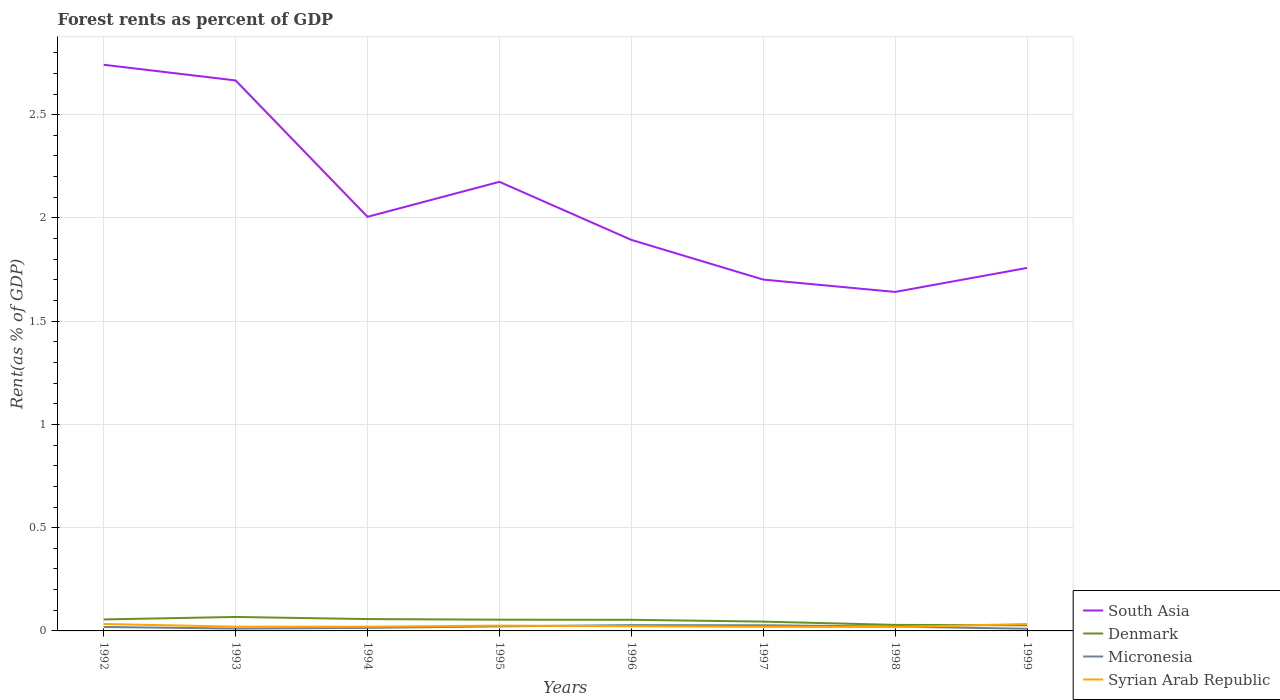How many different coloured lines are there?
Provide a short and direct response. 4. Does the line corresponding to Syrian Arab Republic intersect with the line corresponding to Micronesia?
Offer a very short reply. Yes. Across all years, what is the maximum forest rent in South Asia?
Your answer should be very brief. 1.64. What is the total forest rent in Syrian Arab Republic in the graph?
Your answer should be compact. -0.01. What is the difference between the highest and the second highest forest rent in Micronesia?
Offer a terse response. 0.02. Is the forest rent in South Asia strictly greater than the forest rent in Denmark over the years?
Make the answer very short. No. How many lines are there?
Make the answer very short. 4. How many years are there in the graph?
Provide a succinct answer. 8. Are the values on the major ticks of Y-axis written in scientific E-notation?
Your answer should be very brief. No. How many legend labels are there?
Provide a short and direct response. 4. How are the legend labels stacked?
Your answer should be compact. Vertical. What is the title of the graph?
Offer a terse response. Forest rents as percent of GDP. Does "Angola" appear as one of the legend labels in the graph?
Your answer should be very brief. No. What is the label or title of the X-axis?
Your answer should be very brief. Years. What is the label or title of the Y-axis?
Your answer should be compact. Rent(as % of GDP). What is the Rent(as % of GDP) of South Asia in 1992?
Provide a succinct answer. 2.74. What is the Rent(as % of GDP) of Denmark in 1992?
Your answer should be compact. 0.06. What is the Rent(as % of GDP) in Micronesia in 1992?
Ensure brevity in your answer.  0.02. What is the Rent(as % of GDP) in Syrian Arab Republic in 1992?
Provide a short and direct response. 0.03. What is the Rent(as % of GDP) in South Asia in 1993?
Make the answer very short. 2.67. What is the Rent(as % of GDP) in Denmark in 1993?
Your response must be concise. 0.07. What is the Rent(as % of GDP) in Micronesia in 1993?
Offer a terse response. 0.01. What is the Rent(as % of GDP) in Syrian Arab Republic in 1993?
Your answer should be very brief. 0.02. What is the Rent(as % of GDP) of South Asia in 1994?
Offer a very short reply. 2.01. What is the Rent(as % of GDP) of Denmark in 1994?
Your response must be concise. 0.06. What is the Rent(as % of GDP) in Micronesia in 1994?
Your response must be concise. 0.01. What is the Rent(as % of GDP) of Syrian Arab Republic in 1994?
Give a very brief answer. 0.02. What is the Rent(as % of GDP) in South Asia in 1995?
Your answer should be compact. 2.17. What is the Rent(as % of GDP) of Denmark in 1995?
Give a very brief answer. 0.05. What is the Rent(as % of GDP) of Micronesia in 1995?
Make the answer very short. 0.02. What is the Rent(as % of GDP) in Syrian Arab Republic in 1995?
Provide a short and direct response. 0.03. What is the Rent(as % of GDP) of South Asia in 1996?
Make the answer very short. 1.89. What is the Rent(as % of GDP) of Denmark in 1996?
Your response must be concise. 0.05. What is the Rent(as % of GDP) of Micronesia in 1996?
Offer a very short reply. 0.03. What is the Rent(as % of GDP) in Syrian Arab Republic in 1996?
Offer a very short reply. 0.02. What is the Rent(as % of GDP) of South Asia in 1997?
Keep it short and to the point. 1.7. What is the Rent(as % of GDP) in Denmark in 1997?
Your response must be concise. 0.05. What is the Rent(as % of GDP) of Micronesia in 1997?
Offer a very short reply. 0.03. What is the Rent(as % of GDP) of Syrian Arab Republic in 1997?
Give a very brief answer. 0.02. What is the Rent(as % of GDP) of South Asia in 1998?
Offer a terse response. 1.64. What is the Rent(as % of GDP) of Denmark in 1998?
Your answer should be compact. 0.03. What is the Rent(as % of GDP) of Micronesia in 1998?
Provide a short and direct response. 0.02. What is the Rent(as % of GDP) of Syrian Arab Republic in 1998?
Keep it short and to the point. 0.02. What is the Rent(as % of GDP) of South Asia in 1999?
Provide a short and direct response. 1.76. What is the Rent(as % of GDP) in Denmark in 1999?
Offer a very short reply. 0.03. What is the Rent(as % of GDP) in Micronesia in 1999?
Keep it short and to the point. 0.01. What is the Rent(as % of GDP) in Syrian Arab Republic in 1999?
Make the answer very short. 0.03. Across all years, what is the maximum Rent(as % of GDP) in South Asia?
Your answer should be compact. 2.74. Across all years, what is the maximum Rent(as % of GDP) in Denmark?
Ensure brevity in your answer.  0.07. Across all years, what is the maximum Rent(as % of GDP) of Micronesia?
Your response must be concise. 0.03. Across all years, what is the maximum Rent(as % of GDP) in Syrian Arab Republic?
Your answer should be compact. 0.03. Across all years, what is the minimum Rent(as % of GDP) in South Asia?
Offer a very short reply. 1.64. Across all years, what is the minimum Rent(as % of GDP) of Denmark?
Give a very brief answer. 0.03. Across all years, what is the minimum Rent(as % of GDP) of Micronesia?
Keep it short and to the point. 0.01. Across all years, what is the minimum Rent(as % of GDP) in Syrian Arab Republic?
Your answer should be compact. 0.02. What is the total Rent(as % of GDP) of South Asia in the graph?
Give a very brief answer. 16.58. What is the total Rent(as % of GDP) in Denmark in the graph?
Offer a very short reply. 0.39. What is the total Rent(as % of GDP) in Micronesia in the graph?
Ensure brevity in your answer.  0.15. What is the total Rent(as % of GDP) of Syrian Arab Republic in the graph?
Offer a very short reply. 0.2. What is the difference between the Rent(as % of GDP) of South Asia in 1992 and that in 1993?
Provide a short and direct response. 0.08. What is the difference between the Rent(as % of GDP) in Denmark in 1992 and that in 1993?
Make the answer very short. -0.01. What is the difference between the Rent(as % of GDP) in Micronesia in 1992 and that in 1993?
Your response must be concise. 0.01. What is the difference between the Rent(as % of GDP) in Syrian Arab Republic in 1992 and that in 1993?
Your response must be concise. 0.01. What is the difference between the Rent(as % of GDP) of South Asia in 1992 and that in 1994?
Ensure brevity in your answer.  0.74. What is the difference between the Rent(as % of GDP) of Denmark in 1992 and that in 1994?
Offer a terse response. -0. What is the difference between the Rent(as % of GDP) of Micronesia in 1992 and that in 1994?
Give a very brief answer. 0. What is the difference between the Rent(as % of GDP) in Syrian Arab Republic in 1992 and that in 1994?
Ensure brevity in your answer.  0.01. What is the difference between the Rent(as % of GDP) of South Asia in 1992 and that in 1995?
Offer a terse response. 0.57. What is the difference between the Rent(as % of GDP) in Denmark in 1992 and that in 1995?
Offer a terse response. 0. What is the difference between the Rent(as % of GDP) of Micronesia in 1992 and that in 1995?
Provide a succinct answer. -0. What is the difference between the Rent(as % of GDP) of Syrian Arab Republic in 1992 and that in 1995?
Ensure brevity in your answer.  0.01. What is the difference between the Rent(as % of GDP) in South Asia in 1992 and that in 1996?
Offer a terse response. 0.85. What is the difference between the Rent(as % of GDP) of Denmark in 1992 and that in 1996?
Your answer should be very brief. 0. What is the difference between the Rent(as % of GDP) of Micronesia in 1992 and that in 1996?
Ensure brevity in your answer.  -0.01. What is the difference between the Rent(as % of GDP) in Syrian Arab Republic in 1992 and that in 1996?
Provide a short and direct response. 0.01. What is the difference between the Rent(as % of GDP) in South Asia in 1992 and that in 1997?
Keep it short and to the point. 1.04. What is the difference between the Rent(as % of GDP) in Denmark in 1992 and that in 1997?
Your answer should be very brief. 0.01. What is the difference between the Rent(as % of GDP) in Micronesia in 1992 and that in 1997?
Provide a succinct answer. -0.01. What is the difference between the Rent(as % of GDP) in Syrian Arab Republic in 1992 and that in 1997?
Offer a very short reply. 0.01. What is the difference between the Rent(as % of GDP) of South Asia in 1992 and that in 1998?
Provide a succinct answer. 1.1. What is the difference between the Rent(as % of GDP) in Denmark in 1992 and that in 1998?
Your answer should be very brief. 0.03. What is the difference between the Rent(as % of GDP) of Micronesia in 1992 and that in 1998?
Offer a terse response. -0. What is the difference between the Rent(as % of GDP) in Syrian Arab Republic in 1992 and that in 1998?
Ensure brevity in your answer.  0.01. What is the difference between the Rent(as % of GDP) of South Asia in 1992 and that in 1999?
Offer a terse response. 0.98. What is the difference between the Rent(as % of GDP) in Denmark in 1992 and that in 1999?
Your response must be concise. 0.03. What is the difference between the Rent(as % of GDP) of Micronesia in 1992 and that in 1999?
Give a very brief answer. 0.01. What is the difference between the Rent(as % of GDP) of South Asia in 1993 and that in 1994?
Make the answer very short. 0.66. What is the difference between the Rent(as % of GDP) of Denmark in 1993 and that in 1994?
Keep it short and to the point. 0.01. What is the difference between the Rent(as % of GDP) in Micronesia in 1993 and that in 1994?
Give a very brief answer. -0. What is the difference between the Rent(as % of GDP) of South Asia in 1993 and that in 1995?
Your answer should be compact. 0.49. What is the difference between the Rent(as % of GDP) in Denmark in 1993 and that in 1995?
Keep it short and to the point. 0.01. What is the difference between the Rent(as % of GDP) in Micronesia in 1993 and that in 1995?
Your response must be concise. -0.01. What is the difference between the Rent(as % of GDP) of Syrian Arab Republic in 1993 and that in 1995?
Offer a terse response. -0.01. What is the difference between the Rent(as % of GDP) of South Asia in 1993 and that in 1996?
Your answer should be compact. 0.77. What is the difference between the Rent(as % of GDP) in Denmark in 1993 and that in 1996?
Provide a short and direct response. 0.01. What is the difference between the Rent(as % of GDP) of Micronesia in 1993 and that in 1996?
Offer a terse response. -0.02. What is the difference between the Rent(as % of GDP) in Syrian Arab Republic in 1993 and that in 1996?
Offer a terse response. -0. What is the difference between the Rent(as % of GDP) of South Asia in 1993 and that in 1997?
Your answer should be compact. 0.96. What is the difference between the Rent(as % of GDP) of Denmark in 1993 and that in 1997?
Ensure brevity in your answer.  0.02. What is the difference between the Rent(as % of GDP) of Micronesia in 1993 and that in 1997?
Your answer should be very brief. -0.02. What is the difference between the Rent(as % of GDP) in Syrian Arab Republic in 1993 and that in 1997?
Provide a succinct answer. 0. What is the difference between the Rent(as % of GDP) of South Asia in 1993 and that in 1998?
Ensure brevity in your answer.  1.02. What is the difference between the Rent(as % of GDP) in Denmark in 1993 and that in 1998?
Keep it short and to the point. 0.04. What is the difference between the Rent(as % of GDP) of Micronesia in 1993 and that in 1998?
Keep it short and to the point. -0.01. What is the difference between the Rent(as % of GDP) in Syrian Arab Republic in 1993 and that in 1998?
Make the answer very short. 0. What is the difference between the Rent(as % of GDP) in South Asia in 1993 and that in 1999?
Offer a very short reply. 0.91. What is the difference between the Rent(as % of GDP) of Denmark in 1993 and that in 1999?
Your response must be concise. 0.04. What is the difference between the Rent(as % of GDP) in Micronesia in 1993 and that in 1999?
Your answer should be compact. 0. What is the difference between the Rent(as % of GDP) of Syrian Arab Republic in 1993 and that in 1999?
Make the answer very short. -0.01. What is the difference between the Rent(as % of GDP) of South Asia in 1994 and that in 1995?
Your answer should be very brief. -0.17. What is the difference between the Rent(as % of GDP) of Denmark in 1994 and that in 1995?
Offer a terse response. 0. What is the difference between the Rent(as % of GDP) of Micronesia in 1994 and that in 1995?
Your answer should be compact. -0.01. What is the difference between the Rent(as % of GDP) of Syrian Arab Republic in 1994 and that in 1995?
Offer a very short reply. -0.01. What is the difference between the Rent(as % of GDP) in South Asia in 1994 and that in 1996?
Provide a short and direct response. 0.11. What is the difference between the Rent(as % of GDP) in Denmark in 1994 and that in 1996?
Your response must be concise. 0. What is the difference between the Rent(as % of GDP) of Micronesia in 1994 and that in 1996?
Your response must be concise. -0.01. What is the difference between the Rent(as % of GDP) of Syrian Arab Republic in 1994 and that in 1996?
Ensure brevity in your answer.  -0. What is the difference between the Rent(as % of GDP) of South Asia in 1994 and that in 1997?
Offer a terse response. 0.3. What is the difference between the Rent(as % of GDP) in Denmark in 1994 and that in 1997?
Offer a terse response. 0.01. What is the difference between the Rent(as % of GDP) in Micronesia in 1994 and that in 1997?
Offer a very short reply. -0.01. What is the difference between the Rent(as % of GDP) of Syrian Arab Republic in 1994 and that in 1997?
Ensure brevity in your answer.  0. What is the difference between the Rent(as % of GDP) in South Asia in 1994 and that in 1998?
Provide a succinct answer. 0.36. What is the difference between the Rent(as % of GDP) in Denmark in 1994 and that in 1998?
Ensure brevity in your answer.  0.03. What is the difference between the Rent(as % of GDP) of Micronesia in 1994 and that in 1998?
Give a very brief answer. -0.01. What is the difference between the Rent(as % of GDP) of Syrian Arab Republic in 1994 and that in 1998?
Provide a succinct answer. 0. What is the difference between the Rent(as % of GDP) of South Asia in 1994 and that in 1999?
Make the answer very short. 0.25. What is the difference between the Rent(as % of GDP) in Micronesia in 1994 and that in 1999?
Make the answer very short. 0. What is the difference between the Rent(as % of GDP) in Syrian Arab Republic in 1994 and that in 1999?
Offer a very short reply. -0.01. What is the difference between the Rent(as % of GDP) of South Asia in 1995 and that in 1996?
Provide a short and direct response. 0.28. What is the difference between the Rent(as % of GDP) of Denmark in 1995 and that in 1996?
Provide a succinct answer. 0. What is the difference between the Rent(as % of GDP) in Micronesia in 1995 and that in 1996?
Your answer should be very brief. -0.01. What is the difference between the Rent(as % of GDP) in Syrian Arab Republic in 1995 and that in 1996?
Give a very brief answer. 0. What is the difference between the Rent(as % of GDP) in South Asia in 1995 and that in 1997?
Your answer should be very brief. 0.47. What is the difference between the Rent(as % of GDP) in Denmark in 1995 and that in 1997?
Offer a terse response. 0.01. What is the difference between the Rent(as % of GDP) in Micronesia in 1995 and that in 1997?
Offer a terse response. -0.01. What is the difference between the Rent(as % of GDP) of Syrian Arab Republic in 1995 and that in 1997?
Your response must be concise. 0.01. What is the difference between the Rent(as % of GDP) in South Asia in 1995 and that in 1998?
Offer a terse response. 0.53. What is the difference between the Rent(as % of GDP) in Denmark in 1995 and that in 1998?
Your response must be concise. 0.03. What is the difference between the Rent(as % of GDP) of Syrian Arab Republic in 1995 and that in 1998?
Your answer should be very brief. 0.01. What is the difference between the Rent(as % of GDP) in South Asia in 1995 and that in 1999?
Give a very brief answer. 0.42. What is the difference between the Rent(as % of GDP) in Denmark in 1995 and that in 1999?
Keep it short and to the point. 0.03. What is the difference between the Rent(as % of GDP) of Micronesia in 1995 and that in 1999?
Your answer should be very brief. 0.01. What is the difference between the Rent(as % of GDP) in Syrian Arab Republic in 1995 and that in 1999?
Keep it short and to the point. -0.01. What is the difference between the Rent(as % of GDP) in South Asia in 1996 and that in 1997?
Provide a succinct answer. 0.19. What is the difference between the Rent(as % of GDP) of Denmark in 1996 and that in 1997?
Offer a terse response. 0.01. What is the difference between the Rent(as % of GDP) of Micronesia in 1996 and that in 1997?
Make the answer very short. 0. What is the difference between the Rent(as % of GDP) in Syrian Arab Republic in 1996 and that in 1997?
Keep it short and to the point. 0. What is the difference between the Rent(as % of GDP) of South Asia in 1996 and that in 1998?
Your response must be concise. 0.25. What is the difference between the Rent(as % of GDP) of Denmark in 1996 and that in 1998?
Offer a very short reply. 0.02. What is the difference between the Rent(as % of GDP) in Micronesia in 1996 and that in 1998?
Keep it short and to the point. 0.01. What is the difference between the Rent(as % of GDP) in Syrian Arab Republic in 1996 and that in 1998?
Your response must be concise. 0. What is the difference between the Rent(as % of GDP) of South Asia in 1996 and that in 1999?
Give a very brief answer. 0.14. What is the difference between the Rent(as % of GDP) in Denmark in 1996 and that in 1999?
Offer a very short reply. 0.03. What is the difference between the Rent(as % of GDP) of Micronesia in 1996 and that in 1999?
Keep it short and to the point. 0.02. What is the difference between the Rent(as % of GDP) of Syrian Arab Republic in 1996 and that in 1999?
Make the answer very short. -0.01. What is the difference between the Rent(as % of GDP) in South Asia in 1997 and that in 1998?
Offer a very short reply. 0.06. What is the difference between the Rent(as % of GDP) in Denmark in 1997 and that in 1998?
Give a very brief answer. 0.02. What is the difference between the Rent(as % of GDP) of Micronesia in 1997 and that in 1998?
Your answer should be compact. 0.01. What is the difference between the Rent(as % of GDP) in Syrian Arab Republic in 1997 and that in 1998?
Offer a terse response. 0. What is the difference between the Rent(as % of GDP) of South Asia in 1997 and that in 1999?
Ensure brevity in your answer.  -0.06. What is the difference between the Rent(as % of GDP) in Denmark in 1997 and that in 1999?
Provide a succinct answer. 0.02. What is the difference between the Rent(as % of GDP) in Micronesia in 1997 and that in 1999?
Offer a terse response. 0.02. What is the difference between the Rent(as % of GDP) in Syrian Arab Republic in 1997 and that in 1999?
Keep it short and to the point. -0.01. What is the difference between the Rent(as % of GDP) of South Asia in 1998 and that in 1999?
Provide a short and direct response. -0.12. What is the difference between the Rent(as % of GDP) of Denmark in 1998 and that in 1999?
Give a very brief answer. 0. What is the difference between the Rent(as % of GDP) of Micronesia in 1998 and that in 1999?
Offer a terse response. 0.01. What is the difference between the Rent(as % of GDP) of Syrian Arab Republic in 1998 and that in 1999?
Provide a short and direct response. -0.01. What is the difference between the Rent(as % of GDP) in South Asia in 1992 and the Rent(as % of GDP) in Denmark in 1993?
Keep it short and to the point. 2.67. What is the difference between the Rent(as % of GDP) of South Asia in 1992 and the Rent(as % of GDP) of Micronesia in 1993?
Your response must be concise. 2.73. What is the difference between the Rent(as % of GDP) of South Asia in 1992 and the Rent(as % of GDP) of Syrian Arab Republic in 1993?
Ensure brevity in your answer.  2.72. What is the difference between the Rent(as % of GDP) of Denmark in 1992 and the Rent(as % of GDP) of Micronesia in 1993?
Your answer should be very brief. 0.04. What is the difference between the Rent(as % of GDP) of Denmark in 1992 and the Rent(as % of GDP) of Syrian Arab Republic in 1993?
Keep it short and to the point. 0.04. What is the difference between the Rent(as % of GDP) in Micronesia in 1992 and the Rent(as % of GDP) in Syrian Arab Republic in 1993?
Offer a very short reply. -0. What is the difference between the Rent(as % of GDP) of South Asia in 1992 and the Rent(as % of GDP) of Denmark in 1994?
Your answer should be compact. 2.68. What is the difference between the Rent(as % of GDP) of South Asia in 1992 and the Rent(as % of GDP) of Micronesia in 1994?
Your answer should be very brief. 2.73. What is the difference between the Rent(as % of GDP) in South Asia in 1992 and the Rent(as % of GDP) in Syrian Arab Republic in 1994?
Your response must be concise. 2.72. What is the difference between the Rent(as % of GDP) in Denmark in 1992 and the Rent(as % of GDP) in Micronesia in 1994?
Ensure brevity in your answer.  0.04. What is the difference between the Rent(as % of GDP) in Denmark in 1992 and the Rent(as % of GDP) in Syrian Arab Republic in 1994?
Your answer should be very brief. 0.04. What is the difference between the Rent(as % of GDP) in Micronesia in 1992 and the Rent(as % of GDP) in Syrian Arab Republic in 1994?
Make the answer very short. -0. What is the difference between the Rent(as % of GDP) in South Asia in 1992 and the Rent(as % of GDP) in Denmark in 1995?
Offer a very short reply. 2.69. What is the difference between the Rent(as % of GDP) in South Asia in 1992 and the Rent(as % of GDP) in Micronesia in 1995?
Ensure brevity in your answer.  2.72. What is the difference between the Rent(as % of GDP) of South Asia in 1992 and the Rent(as % of GDP) of Syrian Arab Republic in 1995?
Provide a short and direct response. 2.72. What is the difference between the Rent(as % of GDP) of Denmark in 1992 and the Rent(as % of GDP) of Micronesia in 1995?
Provide a short and direct response. 0.03. What is the difference between the Rent(as % of GDP) of Denmark in 1992 and the Rent(as % of GDP) of Syrian Arab Republic in 1995?
Provide a succinct answer. 0.03. What is the difference between the Rent(as % of GDP) of Micronesia in 1992 and the Rent(as % of GDP) of Syrian Arab Republic in 1995?
Ensure brevity in your answer.  -0.01. What is the difference between the Rent(as % of GDP) in South Asia in 1992 and the Rent(as % of GDP) in Denmark in 1996?
Your answer should be very brief. 2.69. What is the difference between the Rent(as % of GDP) in South Asia in 1992 and the Rent(as % of GDP) in Micronesia in 1996?
Make the answer very short. 2.71. What is the difference between the Rent(as % of GDP) in South Asia in 1992 and the Rent(as % of GDP) in Syrian Arab Republic in 1996?
Give a very brief answer. 2.72. What is the difference between the Rent(as % of GDP) of Denmark in 1992 and the Rent(as % of GDP) of Micronesia in 1996?
Ensure brevity in your answer.  0.03. What is the difference between the Rent(as % of GDP) in Denmark in 1992 and the Rent(as % of GDP) in Syrian Arab Republic in 1996?
Offer a very short reply. 0.03. What is the difference between the Rent(as % of GDP) in Micronesia in 1992 and the Rent(as % of GDP) in Syrian Arab Republic in 1996?
Ensure brevity in your answer.  -0. What is the difference between the Rent(as % of GDP) in South Asia in 1992 and the Rent(as % of GDP) in Denmark in 1997?
Keep it short and to the point. 2.7. What is the difference between the Rent(as % of GDP) of South Asia in 1992 and the Rent(as % of GDP) of Micronesia in 1997?
Your answer should be compact. 2.71. What is the difference between the Rent(as % of GDP) in South Asia in 1992 and the Rent(as % of GDP) in Syrian Arab Republic in 1997?
Your answer should be very brief. 2.72. What is the difference between the Rent(as % of GDP) of Denmark in 1992 and the Rent(as % of GDP) of Micronesia in 1997?
Ensure brevity in your answer.  0.03. What is the difference between the Rent(as % of GDP) in Denmark in 1992 and the Rent(as % of GDP) in Syrian Arab Republic in 1997?
Make the answer very short. 0.04. What is the difference between the Rent(as % of GDP) of Micronesia in 1992 and the Rent(as % of GDP) of Syrian Arab Republic in 1997?
Ensure brevity in your answer.  -0. What is the difference between the Rent(as % of GDP) of South Asia in 1992 and the Rent(as % of GDP) of Denmark in 1998?
Provide a short and direct response. 2.71. What is the difference between the Rent(as % of GDP) in South Asia in 1992 and the Rent(as % of GDP) in Micronesia in 1998?
Offer a terse response. 2.72. What is the difference between the Rent(as % of GDP) of South Asia in 1992 and the Rent(as % of GDP) of Syrian Arab Republic in 1998?
Ensure brevity in your answer.  2.72. What is the difference between the Rent(as % of GDP) of Denmark in 1992 and the Rent(as % of GDP) of Micronesia in 1998?
Offer a terse response. 0.03. What is the difference between the Rent(as % of GDP) of Denmark in 1992 and the Rent(as % of GDP) of Syrian Arab Republic in 1998?
Provide a succinct answer. 0.04. What is the difference between the Rent(as % of GDP) of South Asia in 1992 and the Rent(as % of GDP) of Denmark in 1999?
Your answer should be compact. 2.71. What is the difference between the Rent(as % of GDP) in South Asia in 1992 and the Rent(as % of GDP) in Micronesia in 1999?
Make the answer very short. 2.73. What is the difference between the Rent(as % of GDP) in South Asia in 1992 and the Rent(as % of GDP) in Syrian Arab Republic in 1999?
Keep it short and to the point. 2.71. What is the difference between the Rent(as % of GDP) of Denmark in 1992 and the Rent(as % of GDP) of Micronesia in 1999?
Your response must be concise. 0.05. What is the difference between the Rent(as % of GDP) in Denmark in 1992 and the Rent(as % of GDP) in Syrian Arab Republic in 1999?
Keep it short and to the point. 0.02. What is the difference between the Rent(as % of GDP) in Micronesia in 1992 and the Rent(as % of GDP) in Syrian Arab Republic in 1999?
Your answer should be compact. -0.01. What is the difference between the Rent(as % of GDP) in South Asia in 1993 and the Rent(as % of GDP) in Denmark in 1994?
Offer a very short reply. 2.61. What is the difference between the Rent(as % of GDP) of South Asia in 1993 and the Rent(as % of GDP) of Micronesia in 1994?
Ensure brevity in your answer.  2.65. What is the difference between the Rent(as % of GDP) in South Asia in 1993 and the Rent(as % of GDP) in Syrian Arab Republic in 1994?
Your response must be concise. 2.65. What is the difference between the Rent(as % of GDP) in Denmark in 1993 and the Rent(as % of GDP) in Micronesia in 1994?
Provide a short and direct response. 0.05. What is the difference between the Rent(as % of GDP) of Denmark in 1993 and the Rent(as % of GDP) of Syrian Arab Republic in 1994?
Provide a succinct answer. 0.05. What is the difference between the Rent(as % of GDP) in Micronesia in 1993 and the Rent(as % of GDP) in Syrian Arab Republic in 1994?
Your answer should be very brief. -0.01. What is the difference between the Rent(as % of GDP) of South Asia in 1993 and the Rent(as % of GDP) of Denmark in 1995?
Your answer should be compact. 2.61. What is the difference between the Rent(as % of GDP) in South Asia in 1993 and the Rent(as % of GDP) in Micronesia in 1995?
Offer a terse response. 2.64. What is the difference between the Rent(as % of GDP) of South Asia in 1993 and the Rent(as % of GDP) of Syrian Arab Republic in 1995?
Make the answer very short. 2.64. What is the difference between the Rent(as % of GDP) of Denmark in 1993 and the Rent(as % of GDP) of Micronesia in 1995?
Your response must be concise. 0.05. What is the difference between the Rent(as % of GDP) of Denmark in 1993 and the Rent(as % of GDP) of Syrian Arab Republic in 1995?
Provide a short and direct response. 0.04. What is the difference between the Rent(as % of GDP) of Micronesia in 1993 and the Rent(as % of GDP) of Syrian Arab Republic in 1995?
Make the answer very short. -0.01. What is the difference between the Rent(as % of GDP) in South Asia in 1993 and the Rent(as % of GDP) in Denmark in 1996?
Provide a short and direct response. 2.61. What is the difference between the Rent(as % of GDP) in South Asia in 1993 and the Rent(as % of GDP) in Micronesia in 1996?
Offer a very short reply. 2.64. What is the difference between the Rent(as % of GDP) of South Asia in 1993 and the Rent(as % of GDP) of Syrian Arab Republic in 1996?
Make the answer very short. 2.64. What is the difference between the Rent(as % of GDP) of Denmark in 1993 and the Rent(as % of GDP) of Micronesia in 1996?
Provide a short and direct response. 0.04. What is the difference between the Rent(as % of GDP) of Denmark in 1993 and the Rent(as % of GDP) of Syrian Arab Republic in 1996?
Provide a succinct answer. 0.04. What is the difference between the Rent(as % of GDP) of Micronesia in 1993 and the Rent(as % of GDP) of Syrian Arab Republic in 1996?
Offer a very short reply. -0.01. What is the difference between the Rent(as % of GDP) in South Asia in 1993 and the Rent(as % of GDP) in Denmark in 1997?
Provide a succinct answer. 2.62. What is the difference between the Rent(as % of GDP) in South Asia in 1993 and the Rent(as % of GDP) in Micronesia in 1997?
Your answer should be compact. 2.64. What is the difference between the Rent(as % of GDP) of South Asia in 1993 and the Rent(as % of GDP) of Syrian Arab Republic in 1997?
Keep it short and to the point. 2.65. What is the difference between the Rent(as % of GDP) in Denmark in 1993 and the Rent(as % of GDP) in Micronesia in 1997?
Your response must be concise. 0.04. What is the difference between the Rent(as % of GDP) in Denmark in 1993 and the Rent(as % of GDP) in Syrian Arab Republic in 1997?
Your answer should be very brief. 0.05. What is the difference between the Rent(as % of GDP) in Micronesia in 1993 and the Rent(as % of GDP) in Syrian Arab Republic in 1997?
Make the answer very short. -0.01. What is the difference between the Rent(as % of GDP) in South Asia in 1993 and the Rent(as % of GDP) in Denmark in 1998?
Provide a succinct answer. 2.64. What is the difference between the Rent(as % of GDP) of South Asia in 1993 and the Rent(as % of GDP) of Micronesia in 1998?
Your answer should be very brief. 2.64. What is the difference between the Rent(as % of GDP) of South Asia in 1993 and the Rent(as % of GDP) of Syrian Arab Republic in 1998?
Provide a succinct answer. 2.65. What is the difference between the Rent(as % of GDP) of Denmark in 1993 and the Rent(as % of GDP) of Micronesia in 1998?
Give a very brief answer. 0.05. What is the difference between the Rent(as % of GDP) of Denmark in 1993 and the Rent(as % of GDP) of Syrian Arab Republic in 1998?
Your answer should be compact. 0.05. What is the difference between the Rent(as % of GDP) of Micronesia in 1993 and the Rent(as % of GDP) of Syrian Arab Republic in 1998?
Ensure brevity in your answer.  -0.01. What is the difference between the Rent(as % of GDP) of South Asia in 1993 and the Rent(as % of GDP) of Denmark in 1999?
Ensure brevity in your answer.  2.64. What is the difference between the Rent(as % of GDP) in South Asia in 1993 and the Rent(as % of GDP) in Micronesia in 1999?
Offer a very short reply. 2.66. What is the difference between the Rent(as % of GDP) in South Asia in 1993 and the Rent(as % of GDP) in Syrian Arab Republic in 1999?
Make the answer very short. 2.63. What is the difference between the Rent(as % of GDP) in Denmark in 1993 and the Rent(as % of GDP) in Micronesia in 1999?
Your answer should be compact. 0.06. What is the difference between the Rent(as % of GDP) of Denmark in 1993 and the Rent(as % of GDP) of Syrian Arab Republic in 1999?
Ensure brevity in your answer.  0.03. What is the difference between the Rent(as % of GDP) of Micronesia in 1993 and the Rent(as % of GDP) of Syrian Arab Republic in 1999?
Keep it short and to the point. -0.02. What is the difference between the Rent(as % of GDP) of South Asia in 1994 and the Rent(as % of GDP) of Denmark in 1995?
Provide a short and direct response. 1.95. What is the difference between the Rent(as % of GDP) of South Asia in 1994 and the Rent(as % of GDP) of Micronesia in 1995?
Your answer should be compact. 1.98. What is the difference between the Rent(as % of GDP) in South Asia in 1994 and the Rent(as % of GDP) in Syrian Arab Republic in 1995?
Provide a short and direct response. 1.98. What is the difference between the Rent(as % of GDP) of Denmark in 1994 and the Rent(as % of GDP) of Micronesia in 1995?
Ensure brevity in your answer.  0.04. What is the difference between the Rent(as % of GDP) of Denmark in 1994 and the Rent(as % of GDP) of Syrian Arab Republic in 1995?
Provide a short and direct response. 0.03. What is the difference between the Rent(as % of GDP) in Micronesia in 1994 and the Rent(as % of GDP) in Syrian Arab Republic in 1995?
Provide a succinct answer. -0.01. What is the difference between the Rent(as % of GDP) in South Asia in 1994 and the Rent(as % of GDP) in Denmark in 1996?
Your response must be concise. 1.95. What is the difference between the Rent(as % of GDP) in South Asia in 1994 and the Rent(as % of GDP) in Micronesia in 1996?
Your response must be concise. 1.98. What is the difference between the Rent(as % of GDP) in South Asia in 1994 and the Rent(as % of GDP) in Syrian Arab Republic in 1996?
Make the answer very short. 1.98. What is the difference between the Rent(as % of GDP) of Denmark in 1994 and the Rent(as % of GDP) of Micronesia in 1996?
Offer a very short reply. 0.03. What is the difference between the Rent(as % of GDP) of Denmark in 1994 and the Rent(as % of GDP) of Syrian Arab Republic in 1996?
Keep it short and to the point. 0.03. What is the difference between the Rent(as % of GDP) in Micronesia in 1994 and the Rent(as % of GDP) in Syrian Arab Republic in 1996?
Keep it short and to the point. -0.01. What is the difference between the Rent(as % of GDP) in South Asia in 1994 and the Rent(as % of GDP) in Denmark in 1997?
Keep it short and to the point. 1.96. What is the difference between the Rent(as % of GDP) of South Asia in 1994 and the Rent(as % of GDP) of Micronesia in 1997?
Give a very brief answer. 1.98. What is the difference between the Rent(as % of GDP) of South Asia in 1994 and the Rent(as % of GDP) of Syrian Arab Republic in 1997?
Your answer should be very brief. 1.99. What is the difference between the Rent(as % of GDP) of Denmark in 1994 and the Rent(as % of GDP) of Syrian Arab Republic in 1997?
Make the answer very short. 0.04. What is the difference between the Rent(as % of GDP) of Micronesia in 1994 and the Rent(as % of GDP) of Syrian Arab Republic in 1997?
Keep it short and to the point. -0.01. What is the difference between the Rent(as % of GDP) in South Asia in 1994 and the Rent(as % of GDP) in Denmark in 1998?
Your answer should be compact. 1.98. What is the difference between the Rent(as % of GDP) in South Asia in 1994 and the Rent(as % of GDP) in Micronesia in 1998?
Make the answer very short. 1.98. What is the difference between the Rent(as % of GDP) of South Asia in 1994 and the Rent(as % of GDP) of Syrian Arab Republic in 1998?
Your answer should be compact. 1.99. What is the difference between the Rent(as % of GDP) of Denmark in 1994 and the Rent(as % of GDP) of Micronesia in 1998?
Offer a very short reply. 0.04. What is the difference between the Rent(as % of GDP) of Denmark in 1994 and the Rent(as % of GDP) of Syrian Arab Republic in 1998?
Offer a terse response. 0.04. What is the difference between the Rent(as % of GDP) in Micronesia in 1994 and the Rent(as % of GDP) in Syrian Arab Republic in 1998?
Make the answer very short. -0. What is the difference between the Rent(as % of GDP) of South Asia in 1994 and the Rent(as % of GDP) of Denmark in 1999?
Offer a terse response. 1.98. What is the difference between the Rent(as % of GDP) in South Asia in 1994 and the Rent(as % of GDP) in Micronesia in 1999?
Provide a short and direct response. 1.99. What is the difference between the Rent(as % of GDP) of South Asia in 1994 and the Rent(as % of GDP) of Syrian Arab Republic in 1999?
Make the answer very short. 1.97. What is the difference between the Rent(as % of GDP) in Denmark in 1994 and the Rent(as % of GDP) in Micronesia in 1999?
Make the answer very short. 0.05. What is the difference between the Rent(as % of GDP) of Denmark in 1994 and the Rent(as % of GDP) of Syrian Arab Republic in 1999?
Give a very brief answer. 0.02. What is the difference between the Rent(as % of GDP) in Micronesia in 1994 and the Rent(as % of GDP) in Syrian Arab Republic in 1999?
Offer a very short reply. -0.02. What is the difference between the Rent(as % of GDP) in South Asia in 1995 and the Rent(as % of GDP) in Denmark in 1996?
Make the answer very short. 2.12. What is the difference between the Rent(as % of GDP) of South Asia in 1995 and the Rent(as % of GDP) of Micronesia in 1996?
Your answer should be compact. 2.15. What is the difference between the Rent(as % of GDP) in South Asia in 1995 and the Rent(as % of GDP) in Syrian Arab Republic in 1996?
Offer a terse response. 2.15. What is the difference between the Rent(as % of GDP) of Denmark in 1995 and the Rent(as % of GDP) of Micronesia in 1996?
Offer a very short reply. 0.03. What is the difference between the Rent(as % of GDP) in Denmark in 1995 and the Rent(as % of GDP) in Syrian Arab Republic in 1996?
Ensure brevity in your answer.  0.03. What is the difference between the Rent(as % of GDP) of Micronesia in 1995 and the Rent(as % of GDP) of Syrian Arab Republic in 1996?
Offer a terse response. -0. What is the difference between the Rent(as % of GDP) in South Asia in 1995 and the Rent(as % of GDP) in Denmark in 1997?
Provide a short and direct response. 2.13. What is the difference between the Rent(as % of GDP) in South Asia in 1995 and the Rent(as % of GDP) in Micronesia in 1997?
Your response must be concise. 2.15. What is the difference between the Rent(as % of GDP) of South Asia in 1995 and the Rent(as % of GDP) of Syrian Arab Republic in 1997?
Offer a terse response. 2.15. What is the difference between the Rent(as % of GDP) of Denmark in 1995 and the Rent(as % of GDP) of Micronesia in 1997?
Ensure brevity in your answer.  0.03. What is the difference between the Rent(as % of GDP) in Denmark in 1995 and the Rent(as % of GDP) in Syrian Arab Republic in 1997?
Provide a short and direct response. 0.03. What is the difference between the Rent(as % of GDP) of Micronesia in 1995 and the Rent(as % of GDP) of Syrian Arab Republic in 1997?
Keep it short and to the point. 0. What is the difference between the Rent(as % of GDP) of South Asia in 1995 and the Rent(as % of GDP) of Denmark in 1998?
Keep it short and to the point. 2.15. What is the difference between the Rent(as % of GDP) in South Asia in 1995 and the Rent(as % of GDP) in Micronesia in 1998?
Ensure brevity in your answer.  2.15. What is the difference between the Rent(as % of GDP) of South Asia in 1995 and the Rent(as % of GDP) of Syrian Arab Republic in 1998?
Give a very brief answer. 2.16. What is the difference between the Rent(as % of GDP) of Denmark in 1995 and the Rent(as % of GDP) of Micronesia in 1998?
Provide a short and direct response. 0.03. What is the difference between the Rent(as % of GDP) of Denmark in 1995 and the Rent(as % of GDP) of Syrian Arab Republic in 1998?
Ensure brevity in your answer.  0.04. What is the difference between the Rent(as % of GDP) of Micronesia in 1995 and the Rent(as % of GDP) of Syrian Arab Republic in 1998?
Your response must be concise. 0. What is the difference between the Rent(as % of GDP) of South Asia in 1995 and the Rent(as % of GDP) of Denmark in 1999?
Offer a very short reply. 2.15. What is the difference between the Rent(as % of GDP) in South Asia in 1995 and the Rent(as % of GDP) in Micronesia in 1999?
Your answer should be very brief. 2.16. What is the difference between the Rent(as % of GDP) in South Asia in 1995 and the Rent(as % of GDP) in Syrian Arab Republic in 1999?
Provide a succinct answer. 2.14. What is the difference between the Rent(as % of GDP) in Denmark in 1995 and the Rent(as % of GDP) in Micronesia in 1999?
Make the answer very short. 0.04. What is the difference between the Rent(as % of GDP) of Denmark in 1995 and the Rent(as % of GDP) of Syrian Arab Republic in 1999?
Your answer should be very brief. 0.02. What is the difference between the Rent(as % of GDP) of Micronesia in 1995 and the Rent(as % of GDP) of Syrian Arab Republic in 1999?
Ensure brevity in your answer.  -0.01. What is the difference between the Rent(as % of GDP) of South Asia in 1996 and the Rent(as % of GDP) of Denmark in 1997?
Your answer should be compact. 1.85. What is the difference between the Rent(as % of GDP) in South Asia in 1996 and the Rent(as % of GDP) in Micronesia in 1997?
Keep it short and to the point. 1.87. What is the difference between the Rent(as % of GDP) of South Asia in 1996 and the Rent(as % of GDP) of Syrian Arab Republic in 1997?
Offer a very short reply. 1.87. What is the difference between the Rent(as % of GDP) in Denmark in 1996 and the Rent(as % of GDP) in Micronesia in 1997?
Offer a terse response. 0.03. What is the difference between the Rent(as % of GDP) in Denmark in 1996 and the Rent(as % of GDP) in Syrian Arab Republic in 1997?
Provide a succinct answer. 0.03. What is the difference between the Rent(as % of GDP) in Micronesia in 1996 and the Rent(as % of GDP) in Syrian Arab Republic in 1997?
Offer a very short reply. 0.01. What is the difference between the Rent(as % of GDP) in South Asia in 1996 and the Rent(as % of GDP) in Denmark in 1998?
Keep it short and to the point. 1.86. What is the difference between the Rent(as % of GDP) of South Asia in 1996 and the Rent(as % of GDP) of Micronesia in 1998?
Offer a terse response. 1.87. What is the difference between the Rent(as % of GDP) in South Asia in 1996 and the Rent(as % of GDP) in Syrian Arab Republic in 1998?
Your response must be concise. 1.87. What is the difference between the Rent(as % of GDP) of Denmark in 1996 and the Rent(as % of GDP) of Micronesia in 1998?
Your response must be concise. 0.03. What is the difference between the Rent(as % of GDP) in Denmark in 1996 and the Rent(as % of GDP) in Syrian Arab Republic in 1998?
Keep it short and to the point. 0.04. What is the difference between the Rent(as % of GDP) of Micronesia in 1996 and the Rent(as % of GDP) of Syrian Arab Republic in 1998?
Your response must be concise. 0.01. What is the difference between the Rent(as % of GDP) in South Asia in 1996 and the Rent(as % of GDP) in Denmark in 1999?
Ensure brevity in your answer.  1.87. What is the difference between the Rent(as % of GDP) in South Asia in 1996 and the Rent(as % of GDP) in Micronesia in 1999?
Ensure brevity in your answer.  1.88. What is the difference between the Rent(as % of GDP) in South Asia in 1996 and the Rent(as % of GDP) in Syrian Arab Republic in 1999?
Offer a very short reply. 1.86. What is the difference between the Rent(as % of GDP) of Denmark in 1996 and the Rent(as % of GDP) of Micronesia in 1999?
Provide a succinct answer. 0.04. What is the difference between the Rent(as % of GDP) in Denmark in 1996 and the Rent(as % of GDP) in Syrian Arab Republic in 1999?
Provide a succinct answer. 0.02. What is the difference between the Rent(as % of GDP) in Micronesia in 1996 and the Rent(as % of GDP) in Syrian Arab Republic in 1999?
Offer a terse response. -0.01. What is the difference between the Rent(as % of GDP) in South Asia in 1997 and the Rent(as % of GDP) in Denmark in 1998?
Keep it short and to the point. 1.67. What is the difference between the Rent(as % of GDP) in South Asia in 1997 and the Rent(as % of GDP) in Micronesia in 1998?
Provide a succinct answer. 1.68. What is the difference between the Rent(as % of GDP) of South Asia in 1997 and the Rent(as % of GDP) of Syrian Arab Republic in 1998?
Give a very brief answer. 1.68. What is the difference between the Rent(as % of GDP) in Denmark in 1997 and the Rent(as % of GDP) in Micronesia in 1998?
Keep it short and to the point. 0.02. What is the difference between the Rent(as % of GDP) in Denmark in 1997 and the Rent(as % of GDP) in Syrian Arab Republic in 1998?
Provide a succinct answer. 0.03. What is the difference between the Rent(as % of GDP) in Micronesia in 1997 and the Rent(as % of GDP) in Syrian Arab Republic in 1998?
Offer a terse response. 0.01. What is the difference between the Rent(as % of GDP) in South Asia in 1997 and the Rent(as % of GDP) in Denmark in 1999?
Provide a short and direct response. 1.67. What is the difference between the Rent(as % of GDP) in South Asia in 1997 and the Rent(as % of GDP) in Micronesia in 1999?
Keep it short and to the point. 1.69. What is the difference between the Rent(as % of GDP) of South Asia in 1997 and the Rent(as % of GDP) of Syrian Arab Republic in 1999?
Provide a succinct answer. 1.67. What is the difference between the Rent(as % of GDP) in Denmark in 1997 and the Rent(as % of GDP) in Micronesia in 1999?
Give a very brief answer. 0.03. What is the difference between the Rent(as % of GDP) of Denmark in 1997 and the Rent(as % of GDP) of Syrian Arab Republic in 1999?
Make the answer very short. 0.01. What is the difference between the Rent(as % of GDP) in Micronesia in 1997 and the Rent(as % of GDP) in Syrian Arab Republic in 1999?
Provide a succinct answer. -0.01. What is the difference between the Rent(as % of GDP) in South Asia in 1998 and the Rent(as % of GDP) in Denmark in 1999?
Give a very brief answer. 1.61. What is the difference between the Rent(as % of GDP) in South Asia in 1998 and the Rent(as % of GDP) in Micronesia in 1999?
Offer a terse response. 1.63. What is the difference between the Rent(as % of GDP) of South Asia in 1998 and the Rent(as % of GDP) of Syrian Arab Republic in 1999?
Provide a succinct answer. 1.61. What is the difference between the Rent(as % of GDP) in Denmark in 1998 and the Rent(as % of GDP) in Micronesia in 1999?
Your answer should be compact. 0.02. What is the difference between the Rent(as % of GDP) of Denmark in 1998 and the Rent(as % of GDP) of Syrian Arab Republic in 1999?
Offer a terse response. -0. What is the difference between the Rent(as % of GDP) of Micronesia in 1998 and the Rent(as % of GDP) of Syrian Arab Republic in 1999?
Offer a terse response. -0.01. What is the average Rent(as % of GDP) in South Asia per year?
Offer a very short reply. 2.07. What is the average Rent(as % of GDP) of Denmark per year?
Your answer should be compact. 0.05. What is the average Rent(as % of GDP) of Micronesia per year?
Your answer should be very brief. 0.02. What is the average Rent(as % of GDP) in Syrian Arab Republic per year?
Provide a succinct answer. 0.02. In the year 1992, what is the difference between the Rent(as % of GDP) of South Asia and Rent(as % of GDP) of Denmark?
Offer a very short reply. 2.69. In the year 1992, what is the difference between the Rent(as % of GDP) in South Asia and Rent(as % of GDP) in Micronesia?
Offer a terse response. 2.72. In the year 1992, what is the difference between the Rent(as % of GDP) of South Asia and Rent(as % of GDP) of Syrian Arab Republic?
Provide a succinct answer. 2.71. In the year 1992, what is the difference between the Rent(as % of GDP) in Denmark and Rent(as % of GDP) in Micronesia?
Provide a short and direct response. 0.04. In the year 1992, what is the difference between the Rent(as % of GDP) in Denmark and Rent(as % of GDP) in Syrian Arab Republic?
Make the answer very short. 0.02. In the year 1992, what is the difference between the Rent(as % of GDP) in Micronesia and Rent(as % of GDP) in Syrian Arab Republic?
Your answer should be compact. -0.01. In the year 1993, what is the difference between the Rent(as % of GDP) in South Asia and Rent(as % of GDP) in Denmark?
Offer a very short reply. 2.6. In the year 1993, what is the difference between the Rent(as % of GDP) of South Asia and Rent(as % of GDP) of Micronesia?
Offer a very short reply. 2.65. In the year 1993, what is the difference between the Rent(as % of GDP) of South Asia and Rent(as % of GDP) of Syrian Arab Republic?
Offer a very short reply. 2.65. In the year 1993, what is the difference between the Rent(as % of GDP) in Denmark and Rent(as % of GDP) in Micronesia?
Your answer should be compact. 0.06. In the year 1993, what is the difference between the Rent(as % of GDP) in Denmark and Rent(as % of GDP) in Syrian Arab Republic?
Give a very brief answer. 0.05. In the year 1993, what is the difference between the Rent(as % of GDP) in Micronesia and Rent(as % of GDP) in Syrian Arab Republic?
Give a very brief answer. -0.01. In the year 1994, what is the difference between the Rent(as % of GDP) of South Asia and Rent(as % of GDP) of Denmark?
Make the answer very short. 1.95. In the year 1994, what is the difference between the Rent(as % of GDP) in South Asia and Rent(as % of GDP) in Micronesia?
Offer a very short reply. 1.99. In the year 1994, what is the difference between the Rent(as % of GDP) in South Asia and Rent(as % of GDP) in Syrian Arab Republic?
Your answer should be compact. 1.98. In the year 1994, what is the difference between the Rent(as % of GDP) in Denmark and Rent(as % of GDP) in Micronesia?
Keep it short and to the point. 0.04. In the year 1994, what is the difference between the Rent(as % of GDP) of Denmark and Rent(as % of GDP) of Syrian Arab Republic?
Your response must be concise. 0.04. In the year 1994, what is the difference between the Rent(as % of GDP) of Micronesia and Rent(as % of GDP) of Syrian Arab Republic?
Offer a terse response. -0.01. In the year 1995, what is the difference between the Rent(as % of GDP) in South Asia and Rent(as % of GDP) in Denmark?
Keep it short and to the point. 2.12. In the year 1995, what is the difference between the Rent(as % of GDP) in South Asia and Rent(as % of GDP) in Micronesia?
Offer a very short reply. 2.15. In the year 1995, what is the difference between the Rent(as % of GDP) in South Asia and Rent(as % of GDP) in Syrian Arab Republic?
Provide a succinct answer. 2.15. In the year 1995, what is the difference between the Rent(as % of GDP) of Denmark and Rent(as % of GDP) of Micronesia?
Keep it short and to the point. 0.03. In the year 1995, what is the difference between the Rent(as % of GDP) of Denmark and Rent(as % of GDP) of Syrian Arab Republic?
Offer a very short reply. 0.03. In the year 1995, what is the difference between the Rent(as % of GDP) of Micronesia and Rent(as % of GDP) of Syrian Arab Republic?
Offer a terse response. -0. In the year 1996, what is the difference between the Rent(as % of GDP) in South Asia and Rent(as % of GDP) in Denmark?
Your response must be concise. 1.84. In the year 1996, what is the difference between the Rent(as % of GDP) of South Asia and Rent(as % of GDP) of Micronesia?
Ensure brevity in your answer.  1.87. In the year 1996, what is the difference between the Rent(as % of GDP) of South Asia and Rent(as % of GDP) of Syrian Arab Republic?
Keep it short and to the point. 1.87. In the year 1996, what is the difference between the Rent(as % of GDP) of Denmark and Rent(as % of GDP) of Micronesia?
Your response must be concise. 0.03. In the year 1996, what is the difference between the Rent(as % of GDP) of Denmark and Rent(as % of GDP) of Syrian Arab Republic?
Offer a very short reply. 0.03. In the year 1996, what is the difference between the Rent(as % of GDP) of Micronesia and Rent(as % of GDP) of Syrian Arab Republic?
Offer a terse response. 0.01. In the year 1997, what is the difference between the Rent(as % of GDP) of South Asia and Rent(as % of GDP) of Denmark?
Your response must be concise. 1.66. In the year 1997, what is the difference between the Rent(as % of GDP) of South Asia and Rent(as % of GDP) of Micronesia?
Your answer should be compact. 1.67. In the year 1997, what is the difference between the Rent(as % of GDP) of South Asia and Rent(as % of GDP) of Syrian Arab Republic?
Offer a very short reply. 1.68. In the year 1997, what is the difference between the Rent(as % of GDP) of Denmark and Rent(as % of GDP) of Micronesia?
Give a very brief answer. 0.02. In the year 1997, what is the difference between the Rent(as % of GDP) in Denmark and Rent(as % of GDP) in Syrian Arab Republic?
Ensure brevity in your answer.  0.03. In the year 1997, what is the difference between the Rent(as % of GDP) of Micronesia and Rent(as % of GDP) of Syrian Arab Republic?
Offer a terse response. 0.01. In the year 1998, what is the difference between the Rent(as % of GDP) in South Asia and Rent(as % of GDP) in Denmark?
Provide a succinct answer. 1.61. In the year 1998, what is the difference between the Rent(as % of GDP) of South Asia and Rent(as % of GDP) of Micronesia?
Your response must be concise. 1.62. In the year 1998, what is the difference between the Rent(as % of GDP) in South Asia and Rent(as % of GDP) in Syrian Arab Republic?
Offer a very short reply. 1.62. In the year 1998, what is the difference between the Rent(as % of GDP) of Denmark and Rent(as % of GDP) of Micronesia?
Your answer should be compact. 0.01. In the year 1998, what is the difference between the Rent(as % of GDP) in Denmark and Rent(as % of GDP) in Syrian Arab Republic?
Give a very brief answer. 0.01. In the year 1998, what is the difference between the Rent(as % of GDP) of Micronesia and Rent(as % of GDP) of Syrian Arab Republic?
Provide a succinct answer. 0. In the year 1999, what is the difference between the Rent(as % of GDP) in South Asia and Rent(as % of GDP) in Denmark?
Offer a very short reply. 1.73. In the year 1999, what is the difference between the Rent(as % of GDP) in South Asia and Rent(as % of GDP) in Micronesia?
Your answer should be compact. 1.75. In the year 1999, what is the difference between the Rent(as % of GDP) of South Asia and Rent(as % of GDP) of Syrian Arab Republic?
Your response must be concise. 1.72. In the year 1999, what is the difference between the Rent(as % of GDP) in Denmark and Rent(as % of GDP) in Micronesia?
Offer a very short reply. 0.02. In the year 1999, what is the difference between the Rent(as % of GDP) in Denmark and Rent(as % of GDP) in Syrian Arab Republic?
Your answer should be compact. -0.01. In the year 1999, what is the difference between the Rent(as % of GDP) of Micronesia and Rent(as % of GDP) of Syrian Arab Republic?
Keep it short and to the point. -0.02. What is the ratio of the Rent(as % of GDP) in South Asia in 1992 to that in 1993?
Your answer should be very brief. 1.03. What is the ratio of the Rent(as % of GDP) of Denmark in 1992 to that in 1993?
Make the answer very short. 0.82. What is the ratio of the Rent(as % of GDP) in Micronesia in 1992 to that in 1993?
Your answer should be very brief. 1.68. What is the ratio of the Rent(as % of GDP) in Syrian Arab Republic in 1992 to that in 1993?
Offer a very short reply. 1.63. What is the ratio of the Rent(as % of GDP) of South Asia in 1992 to that in 1994?
Make the answer very short. 1.37. What is the ratio of the Rent(as % of GDP) in Denmark in 1992 to that in 1994?
Provide a short and direct response. 0.97. What is the ratio of the Rent(as % of GDP) in Micronesia in 1992 to that in 1994?
Provide a short and direct response. 1.3. What is the ratio of the Rent(as % of GDP) of Syrian Arab Republic in 1992 to that in 1994?
Offer a terse response. 1.64. What is the ratio of the Rent(as % of GDP) of South Asia in 1992 to that in 1995?
Provide a short and direct response. 1.26. What is the ratio of the Rent(as % of GDP) in Denmark in 1992 to that in 1995?
Make the answer very short. 1.02. What is the ratio of the Rent(as % of GDP) in Micronesia in 1992 to that in 1995?
Ensure brevity in your answer.  0.87. What is the ratio of the Rent(as % of GDP) in Syrian Arab Republic in 1992 to that in 1995?
Offer a terse response. 1.3. What is the ratio of the Rent(as % of GDP) of South Asia in 1992 to that in 1996?
Offer a terse response. 1.45. What is the ratio of the Rent(as % of GDP) of Denmark in 1992 to that in 1996?
Your answer should be very brief. 1.03. What is the ratio of the Rent(as % of GDP) of Micronesia in 1992 to that in 1996?
Give a very brief answer. 0.68. What is the ratio of the Rent(as % of GDP) of Syrian Arab Republic in 1992 to that in 1996?
Your answer should be compact. 1.47. What is the ratio of the Rent(as % of GDP) of South Asia in 1992 to that in 1997?
Your answer should be compact. 1.61. What is the ratio of the Rent(as % of GDP) in Denmark in 1992 to that in 1997?
Provide a succinct answer. 1.23. What is the ratio of the Rent(as % of GDP) of Micronesia in 1992 to that in 1997?
Provide a short and direct response. 0.7. What is the ratio of the Rent(as % of GDP) of Syrian Arab Republic in 1992 to that in 1997?
Offer a terse response. 1.69. What is the ratio of the Rent(as % of GDP) of South Asia in 1992 to that in 1998?
Offer a terse response. 1.67. What is the ratio of the Rent(as % of GDP) in Denmark in 1992 to that in 1998?
Give a very brief answer. 1.9. What is the ratio of the Rent(as % of GDP) of Micronesia in 1992 to that in 1998?
Offer a very short reply. 0.91. What is the ratio of the Rent(as % of GDP) of Syrian Arab Republic in 1992 to that in 1998?
Provide a succinct answer. 1.79. What is the ratio of the Rent(as % of GDP) in South Asia in 1992 to that in 1999?
Your answer should be very brief. 1.56. What is the ratio of the Rent(as % of GDP) in Denmark in 1992 to that in 1999?
Offer a terse response. 2.03. What is the ratio of the Rent(as % of GDP) in Micronesia in 1992 to that in 1999?
Keep it short and to the point. 1.81. What is the ratio of the Rent(as % of GDP) of South Asia in 1993 to that in 1994?
Provide a succinct answer. 1.33. What is the ratio of the Rent(as % of GDP) of Denmark in 1993 to that in 1994?
Provide a short and direct response. 1.18. What is the ratio of the Rent(as % of GDP) in Micronesia in 1993 to that in 1994?
Offer a terse response. 0.78. What is the ratio of the Rent(as % of GDP) in Syrian Arab Republic in 1993 to that in 1994?
Offer a terse response. 1.01. What is the ratio of the Rent(as % of GDP) of South Asia in 1993 to that in 1995?
Keep it short and to the point. 1.23. What is the ratio of the Rent(as % of GDP) in Denmark in 1993 to that in 1995?
Provide a short and direct response. 1.24. What is the ratio of the Rent(as % of GDP) of Micronesia in 1993 to that in 1995?
Provide a succinct answer. 0.52. What is the ratio of the Rent(as % of GDP) in Syrian Arab Republic in 1993 to that in 1995?
Ensure brevity in your answer.  0.8. What is the ratio of the Rent(as % of GDP) in South Asia in 1993 to that in 1996?
Your answer should be very brief. 1.41. What is the ratio of the Rent(as % of GDP) of Denmark in 1993 to that in 1996?
Give a very brief answer. 1.26. What is the ratio of the Rent(as % of GDP) of Micronesia in 1993 to that in 1996?
Make the answer very short. 0.4. What is the ratio of the Rent(as % of GDP) of Syrian Arab Republic in 1993 to that in 1996?
Offer a very short reply. 0.9. What is the ratio of the Rent(as % of GDP) of South Asia in 1993 to that in 1997?
Your response must be concise. 1.57. What is the ratio of the Rent(as % of GDP) of Denmark in 1993 to that in 1997?
Your answer should be very brief. 1.5. What is the ratio of the Rent(as % of GDP) of Micronesia in 1993 to that in 1997?
Your answer should be compact. 0.41. What is the ratio of the Rent(as % of GDP) of Syrian Arab Republic in 1993 to that in 1997?
Your response must be concise. 1.04. What is the ratio of the Rent(as % of GDP) of South Asia in 1993 to that in 1998?
Keep it short and to the point. 1.62. What is the ratio of the Rent(as % of GDP) in Denmark in 1993 to that in 1998?
Keep it short and to the point. 2.32. What is the ratio of the Rent(as % of GDP) in Micronesia in 1993 to that in 1998?
Your answer should be very brief. 0.54. What is the ratio of the Rent(as % of GDP) of Syrian Arab Republic in 1993 to that in 1998?
Your response must be concise. 1.1. What is the ratio of the Rent(as % of GDP) of South Asia in 1993 to that in 1999?
Your answer should be very brief. 1.52. What is the ratio of the Rent(as % of GDP) in Denmark in 1993 to that in 1999?
Offer a terse response. 2.47. What is the ratio of the Rent(as % of GDP) in Micronesia in 1993 to that in 1999?
Offer a terse response. 1.08. What is the ratio of the Rent(as % of GDP) of Syrian Arab Republic in 1993 to that in 1999?
Provide a succinct answer. 0.62. What is the ratio of the Rent(as % of GDP) in South Asia in 1994 to that in 1995?
Give a very brief answer. 0.92. What is the ratio of the Rent(as % of GDP) in Denmark in 1994 to that in 1995?
Offer a terse response. 1.06. What is the ratio of the Rent(as % of GDP) in Micronesia in 1994 to that in 1995?
Provide a succinct answer. 0.67. What is the ratio of the Rent(as % of GDP) of Syrian Arab Republic in 1994 to that in 1995?
Provide a short and direct response. 0.79. What is the ratio of the Rent(as % of GDP) of South Asia in 1994 to that in 1996?
Keep it short and to the point. 1.06. What is the ratio of the Rent(as % of GDP) in Denmark in 1994 to that in 1996?
Your answer should be very brief. 1.07. What is the ratio of the Rent(as % of GDP) of Micronesia in 1994 to that in 1996?
Your response must be concise. 0.52. What is the ratio of the Rent(as % of GDP) of Syrian Arab Republic in 1994 to that in 1996?
Your answer should be compact. 0.9. What is the ratio of the Rent(as % of GDP) in South Asia in 1994 to that in 1997?
Provide a short and direct response. 1.18. What is the ratio of the Rent(as % of GDP) of Denmark in 1994 to that in 1997?
Keep it short and to the point. 1.27. What is the ratio of the Rent(as % of GDP) of Micronesia in 1994 to that in 1997?
Give a very brief answer. 0.54. What is the ratio of the Rent(as % of GDP) of Syrian Arab Republic in 1994 to that in 1997?
Ensure brevity in your answer.  1.03. What is the ratio of the Rent(as % of GDP) of South Asia in 1994 to that in 1998?
Keep it short and to the point. 1.22. What is the ratio of the Rent(as % of GDP) in Denmark in 1994 to that in 1998?
Provide a short and direct response. 1.97. What is the ratio of the Rent(as % of GDP) of Micronesia in 1994 to that in 1998?
Your answer should be compact. 0.7. What is the ratio of the Rent(as % of GDP) in Syrian Arab Republic in 1994 to that in 1998?
Your answer should be very brief. 1.09. What is the ratio of the Rent(as % of GDP) of South Asia in 1994 to that in 1999?
Ensure brevity in your answer.  1.14. What is the ratio of the Rent(as % of GDP) in Denmark in 1994 to that in 1999?
Offer a terse response. 2.09. What is the ratio of the Rent(as % of GDP) in Micronesia in 1994 to that in 1999?
Provide a short and direct response. 1.39. What is the ratio of the Rent(as % of GDP) of Syrian Arab Republic in 1994 to that in 1999?
Provide a short and direct response. 0.61. What is the ratio of the Rent(as % of GDP) of South Asia in 1995 to that in 1996?
Provide a succinct answer. 1.15. What is the ratio of the Rent(as % of GDP) in Denmark in 1995 to that in 1996?
Keep it short and to the point. 1.01. What is the ratio of the Rent(as % of GDP) in Micronesia in 1995 to that in 1996?
Your answer should be very brief. 0.78. What is the ratio of the Rent(as % of GDP) in Syrian Arab Republic in 1995 to that in 1996?
Ensure brevity in your answer.  1.13. What is the ratio of the Rent(as % of GDP) in South Asia in 1995 to that in 1997?
Keep it short and to the point. 1.28. What is the ratio of the Rent(as % of GDP) of Denmark in 1995 to that in 1997?
Give a very brief answer. 1.21. What is the ratio of the Rent(as % of GDP) of Micronesia in 1995 to that in 1997?
Your answer should be very brief. 0.8. What is the ratio of the Rent(as % of GDP) in Syrian Arab Republic in 1995 to that in 1997?
Your response must be concise. 1.3. What is the ratio of the Rent(as % of GDP) of South Asia in 1995 to that in 1998?
Offer a very short reply. 1.32. What is the ratio of the Rent(as % of GDP) in Denmark in 1995 to that in 1998?
Provide a succinct answer. 1.86. What is the ratio of the Rent(as % of GDP) in Micronesia in 1995 to that in 1998?
Keep it short and to the point. 1.05. What is the ratio of the Rent(as % of GDP) of Syrian Arab Republic in 1995 to that in 1998?
Your response must be concise. 1.38. What is the ratio of the Rent(as % of GDP) of South Asia in 1995 to that in 1999?
Provide a succinct answer. 1.24. What is the ratio of the Rent(as % of GDP) of Denmark in 1995 to that in 1999?
Your answer should be compact. 1.98. What is the ratio of the Rent(as % of GDP) of Micronesia in 1995 to that in 1999?
Offer a very short reply. 2.09. What is the ratio of the Rent(as % of GDP) of Syrian Arab Republic in 1995 to that in 1999?
Your answer should be very brief. 0.77. What is the ratio of the Rent(as % of GDP) of South Asia in 1996 to that in 1997?
Provide a succinct answer. 1.11. What is the ratio of the Rent(as % of GDP) in Denmark in 1996 to that in 1997?
Your answer should be very brief. 1.19. What is the ratio of the Rent(as % of GDP) in Micronesia in 1996 to that in 1997?
Keep it short and to the point. 1.03. What is the ratio of the Rent(as % of GDP) in Syrian Arab Republic in 1996 to that in 1997?
Keep it short and to the point. 1.15. What is the ratio of the Rent(as % of GDP) of South Asia in 1996 to that in 1998?
Your answer should be compact. 1.15. What is the ratio of the Rent(as % of GDP) of Denmark in 1996 to that in 1998?
Ensure brevity in your answer.  1.84. What is the ratio of the Rent(as % of GDP) in Micronesia in 1996 to that in 1998?
Offer a terse response. 1.34. What is the ratio of the Rent(as % of GDP) in Syrian Arab Republic in 1996 to that in 1998?
Offer a terse response. 1.22. What is the ratio of the Rent(as % of GDP) of South Asia in 1996 to that in 1999?
Ensure brevity in your answer.  1.08. What is the ratio of the Rent(as % of GDP) of Denmark in 1996 to that in 1999?
Give a very brief answer. 1.96. What is the ratio of the Rent(as % of GDP) of Micronesia in 1996 to that in 1999?
Offer a terse response. 2.68. What is the ratio of the Rent(as % of GDP) of Syrian Arab Republic in 1996 to that in 1999?
Keep it short and to the point. 0.68. What is the ratio of the Rent(as % of GDP) in South Asia in 1997 to that in 1998?
Offer a terse response. 1.04. What is the ratio of the Rent(as % of GDP) of Denmark in 1997 to that in 1998?
Your answer should be compact. 1.54. What is the ratio of the Rent(as % of GDP) of Micronesia in 1997 to that in 1998?
Your answer should be compact. 1.31. What is the ratio of the Rent(as % of GDP) in Syrian Arab Republic in 1997 to that in 1998?
Ensure brevity in your answer.  1.06. What is the ratio of the Rent(as % of GDP) in South Asia in 1997 to that in 1999?
Your answer should be very brief. 0.97. What is the ratio of the Rent(as % of GDP) of Denmark in 1997 to that in 1999?
Keep it short and to the point. 1.64. What is the ratio of the Rent(as % of GDP) in Micronesia in 1997 to that in 1999?
Your answer should be very brief. 2.61. What is the ratio of the Rent(as % of GDP) of Syrian Arab Republic in 1997 to that in 1999?
Give a very brief answer. 0.59. What is the ratio of the Rent(as % of GDP) of South Asia in 1998 to that in 1999?
Give a very brief answer. 0.93. What is the ratio of the Rent(as % of GDP) in Denmark in 1998 to that in 1999?
Ensure brevity in your answer.  1.06. What is the ratio of the Rent(as % of GDP) of Micronesia in 1998 to that in 1999?
Ensure brevity in your answer.  2. What is the ratio of the Rent(as % of GDP) in Syrian Arab Republic in 1998 to that in 1999?
Provide a short and direct response. 0.56. What is the difference between the highest and the second highest Rent(as % of GDP) of South Asia?
Give a very brief answer. 0.08. What is the difference between the highest and the second highest Rent(as % of GDP) of Denmark?
Give a very brief answer. 0.01. What is the difference between the highest and the second highest Rent(as % of GDP) of Micronesia?
Keep it short and to the point. 0. What is the difference between the highest and the second highest Rent(as % of GDP) of Syrian Arab Republic?
Your answer should be very brief. 0. What is the difference between the highest and the lowest Rent(as % of GDP) in South Asia?
Provide a short and direct response. 1.1. What is the difference between the highest and the lowest Rent(as % of GDP) of Denmark?
Make the answer very short. 0.04. What is the difference between the highest and the lowest Rent(as % of GDP) of Micronesia?
Ensure brevity in your answer.  0.02. What is the difference between the highest and the lowest Rent(as % of GDP) in Syrian Arab Republic?
Provide a succinct answer. 0.01. 